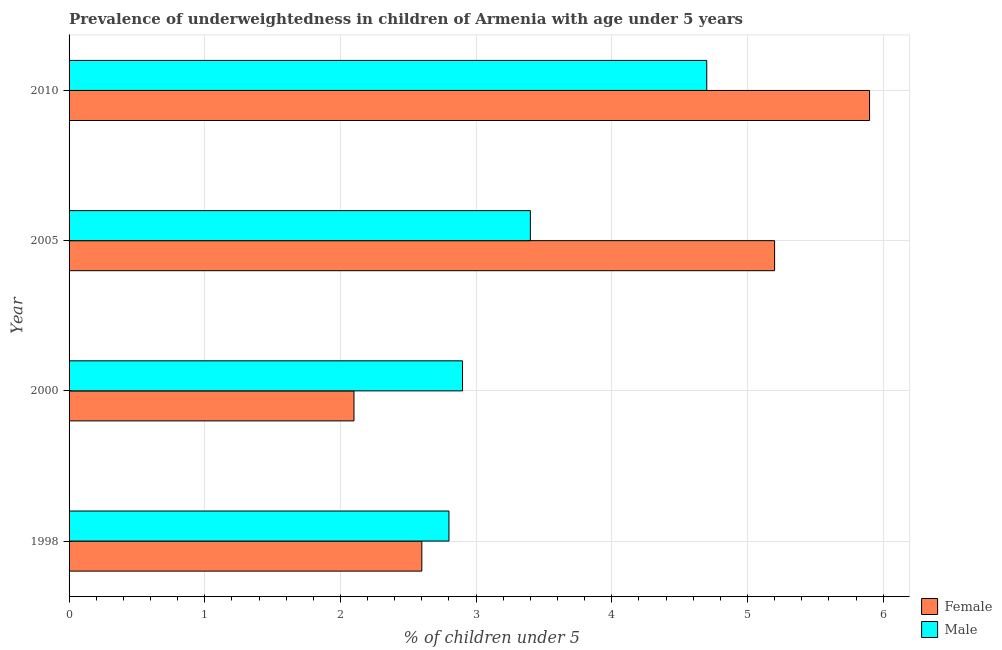How many different coloured bars are there?
Your answer should be compact. 2. How many groups of bars are there?
Offer a very short reply. 4. Are the number of bars per tick equal to the number of legend labels?
Provide a short and direct response. Yes. Are the number of bars on each tick of the Y-axis equal?
Your answer should be compact. Yes. How many bars are there on the 3rd tick from the top?
Your response must be concise. 2. How many bars are there on the 2nd tick from the bottom?
Provide a short and direct response. 2. What is the label of the 3rd group of bars from the top?
Provide a succinct answer. 2000. What is the percentage of underweighted male children in 2000?
Your answer should be compact. 2.9. Across all years, what is the maximum percentage of underweighted female children?
Provide a short and direct response. 5.9. Across all years, what is the minimum percentage of underweighted female children?
Provide a succinct answer. 2.1. What is the total percentage of underweighted male children in the graph?
Offer a terse response. 13.8. What is the difference between the percentage of underweighted female children in 1998 and that in 2005?
Provide a short and direct response. -2.6. What is the difference between the percentage of underweighted male children in 2000 and the percentage of underweighted female children in 1998?
Your answer should be compact. 0.3. What is the average percentage of underweighted male children per year?
Provide a short and direct response. 3.45. In how many years, is the percentage of underweighted male children greater than 5.2 %?
Give a very brief answer. 0. What is the ratio of the percentage of underweighted male children in 2000 to that in 2010?
Provide a short and direct response. 0.62. Is the difference between the percentage of underweighted female children in 2000 and 2005 greater than the difference between the percentage of underweighted male children in 2000 and 2005?
Your answer should be compact. No. In how many years, is the percentage of underweighted male children greater than the average percentage of underweighted male children taken over all years?
Offer a very short reply. 1. What does the 1st bar from the top in 2000 represents?
Make the answer very short. Male. Are all the bars in the graph horizontal?
Offer a very short reply. Yes. What is the difference between two consecutive major ticks on the X-axis?
Your response must be concise. 1. Where does the legend appear in the graph?
Keep it short and to the point. Bottom right. How many legend labels are there?
Make the answer very short. 2. How are the legend labels stacked?
Make the answer very short. Vertical. What is the title of the graph?
Your response must be concise. Prevalence of underweightedness in children of Armenia with age under 5 years. Does "Food and tobacco" appear as one of the legend labels in the graph?
Offer a very short reply. No. What is the label or title of the X-axis?
Provide a succinct answer.  % of children under 5. What is the label or title of the Y-axis?
Offer a terse response. Year. What is the  % of children under 5 of Female in 1998?
Make the answer very short. 2.6. What is the  % of children under 5 in Male in 1998?
Your answer should be compact. 2.8. What is the  % of children under 5 of Female in 2000?
Your answer should be compact. 2.1. What is the  % of children under 5 of Male in 2000?
Provide a short and direct response. 2.9. What is the  % of children under 5 of Female in 2005?
Keep it short and to the point. 5.2. What is the  % of children under 5 in Male in 2005?
Ensure brevity in your answer.  3.4. What is the  % of children under 5 of Female in 2010?
Your response must be concise. 5.9. What is the  % of children under 5 of Male in 2010?
Offer a very short reply. 4.7. Across all years, what is the maximum  % of children under 5 of Female?
Ensure brevity in your answer.  5.9. Across all years, what is the maximum  % of children under 5 of Male?
Offer a very short reply. 4.7. Across all years, what is the minimum  % of children under 5 in Female?
Offer a very short reply. 2.1. Across all years, what is the minimum  % of children under 5 in Male?
Offer a terse response. 2.8. What is the total  % of children under 5 in Male in the graph?
Your response must be concise. 13.8. What is the difference between the  % of children under 5 of Female in 1998 and that in 2000?
Your answer should be compact. 0.5. What is the difference between the  % of children under 5 of Male in 1998 and that in 2000?
Your response must be concise. -0.1. What is the difference between the  % of children under 5 of Female in 1998 and that in 2010?
Provide a succinct answer. -3.3. What is the difference between the  % of children under 5 in Female in 2000 and that in 2005?
Offer a very short reply. -3.1. What is the difference between the  % of children under 5 in Male in 2000 and that in 2005?
Offer a very short reply. -0.5. What is the difference between the  % of children under 5 of Male in 2000 and that in 2010?
Give a very brief answer. -1.8. What is the difference between the  % of children under 5 of Female in 2005 and that in 2010?
Offer a very short reply. -0.7. What is the difference between the  % of children under 5 of Male in 2005 and that in 2010?
Offer a very short reply. -1.3. What is the difference between the  % of children under 5 in Female in 1998 and the  % of children under 5 in Male in 2000?
Your answer should be compact. -0.3. What is the difference between the  % of children under 5 in Female in 1998 and the  % of children under 5 in Male in 2005?
Make the answer very short. -0.8. What is the difference between the  % of children under 5 in Female in 1998 and the  % of children under 5 in Male in 2010?
Offer a very short reply. -2.1. What is the difference between the  % of children under 5 in Female in 2000 and the  % of children under 5 in Male in 2005?
Offer a terse response. -1.3. What is the average  % of children under 5 of Female per year?
Your answer should be compact. 3.95. What is the average  % of children under 5 in Male per year?
Provide a succinct answer. 3.45. In the year 1998, what is the difference between the  % of children under 5 of Female and  % of children under 5 of Male?
Ensure brevity in your answer.  -0.2. In the year 2000, what is the difference between the  % of children under 5 of Female and  % of children under 5 of Male?
Your response must be concise. -0.8. What is the ratio of the  % of children under 5 of Female in 1998 to that in 2000?
Provide a succinct answer. 1.24. What is the ratio of the  % of children under 5 in Male in 1998 to that in 2000?
Give a very brief answer. 0.97. What is the ratio of the  % of children under 5 of Male in 1998 to that in 2005?
Your answer should be compact. 0.82. What is the ratio of the  % of children under 5 in Female in 1998 to that in 2010?
Ensure brevity in your answer.  0.44. What is the ratio of the  % of children under 5 in Male in 1998 to that in 2010?
Give a very brief answer. 0.6. What is the ratio of the  % of children under 5 of Female in 2000 to that in 2005?
Provide a short and direct response. 0.4. What is the ratio of the  % of children under 5 in Male in 2000 to that in 2005?
Make the answer very short. 0.85. What is the ratio of the  % of children under 5 of Female in 2000 to that in 2010?
Your answer should be very brief. 0.36. What is the ratio of the  % of children under 5 of Male in 2000 to that in 2010?
Provide a succinct answer. 0.62. What is the ratio of the  % of children under 5 in Female in 2005 to that in 2010?
Your response must be concise. 0.88. What is the ratio of the  % of children under 5 in Male in 2005 to that in 2010?
Your response must be concise. 0.72. What is the difference between the highest and the lowest  % of children under 5 in Male?
Your response must be concise. 1.9. 